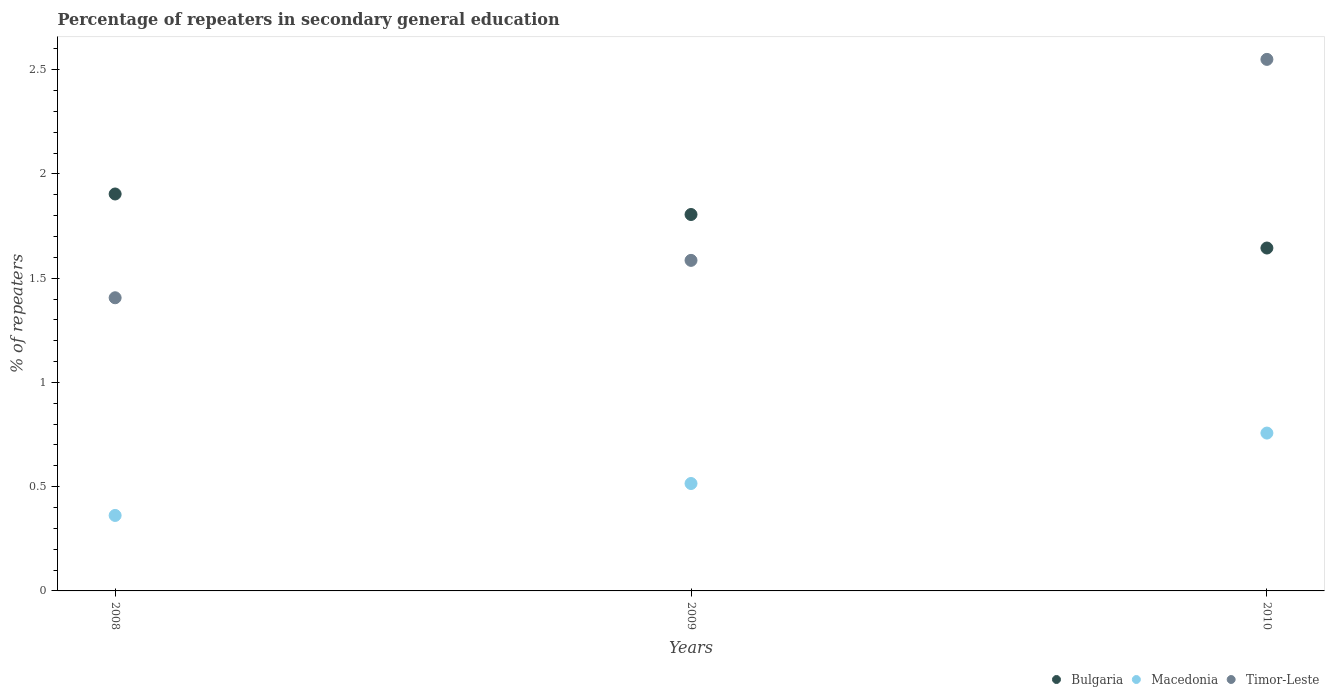How many different coloured dotlines are there?
Offer a terse response. 3. What is the percentage of repeaters in secondary general education in Bulgaria in 2009?
Ensure brevity in your answer.  1.81. Across all years, what is the maximum percentage of repeaters in secondary general education in Macedonia?
Keep it short and to the point. 0.76. Across all years, what is the minimum percentage of repeaters in secondary general education in Timor-Leste?
Your answer should be very brief. 1.41. In which year was the percentage of repeaters in secondary general education in Bulgaria maximum?
Your answer should be compact. 2008. What is the total percentage of repeaters in secondary general education in Macedonia in the graph?
Keep it short and to the point. 1.63. What is the difference between the percentage of repeaters in secondary general education in Timor-Leste in 2009 and that in 2010?
Make the answer very short. -0.96. What is the difference between the percentage of repeaters in secondary general education in Macedonia in 2010 and the percentage of repeaters in secondary general education in Bulgaria in 2008?
Provide a succinct answer. -1.15. What is the average percentage of repeaters in secondary general education in Macedonia per year?
Your answer should be compact. 0.54. In the year 2009, what is the difference between the percentage of repeaters in secondary general education in Timor-Leste and percentage of repeaters in secondary general education in Macedonia?
Provide a succinct answer. 1.07. In how many years, is the percentage of repeaters in secondary general education in Timor-Leste greater than 1.5 %?
Give a very brief answer. 2. What is the ratio of the percentage of repeaters in secondary general education in Bulgaria in 2008 to that in 2010?
Provide a succinct answer. 1.16. What is the difference between the highest and the second highest percentage of repeaters in secondary general education in Macedonia?
Your answer should be compact. 0.24. What is the difference between the highest and the lowest percentage of repeaters in secondary general education in Macedonia?
Offer a very short reply. 0.4. Is the sum of the percentage of repeaters in secondary general education in Timor-Leste in 2008 and 2009 greater than the maximum percentage of repeaters in secondary general education in Bulgaria across all years?
Your response must be concise. Yes. Is the percentage of repeaters in secondary general education in Macedonia strictly greater than the percentage of repeaters in secondary general education in Bulgaria over the years?
Provide a short and direct response. No. What is the difference between two consecutive major ticks on the Y-axis?
Provide a succinct answer. 0.5. How many legend labels are there?
Keep it short and to the point. 3. What is the title of the graph?
Offer a very short reply. Percentage of repeaters in secondary general education. What is the label or title of the X-axis?
Provide a succinct answer. Years. What is the label or title of the Y-axis?
Provide a succinct answer. % of repeaters. What is the % of repeaters in Bulgaria in 2008?
Your response must be concise. 1.9. What is the % of repeaters in Macedonia in 2008?
Your response must be concise. 0.36. What is the % of repeaters of Timor-Leste in 2008?
Offer a very short reply. 1.41. What is the % of repeaters in Bulgaria in 2009?
Your answer should be compact. 1.81. What is the % of repeaters in Macedonia in 2009?
Keep it short and to the point. 0.52. What is the % of repeaters in Timor-Leste in 2009?
Offer a terse response. 1.59. What is the % of repeaters of Bulgaria in 2010?
Provide a succinct answer. 1.64. What is the % of repeaters in Macedonia in 2010?
Your answer should be compact. 0.76. What is the % of repeaters of Timor-Leste in 2010?
Provide a short and direct response. 2.55. Across all years, what is the maximum % of repeaters in Bulgaria?
Your response must be concise. 1.9. Across all years, what is the maximum % of repeaters of Macedonia?
Offer a very short reply. 0.76. Across all years, what is the maximum % of repeaters in Timor-Leste?
Your response must be concise. 2.55. Across all years, what is the minimum % of repeaters of Bulgaria?
Ensure brevity in your answer.  1.64. Across all years, what is the minimum % of repeaters in Macedonia?
Give a very brief answer. 0.36. Across all years, what is the minimum % of repeaters of Timor-Leste?
Offer a very short reply. 1.41. What is the total % of repeaters in Bulgaria in the graph?
Your answer should be very brief. 5.35. What is the total % of repeaters of Macedonia in the graph?
Keep it short and to the point. 1.63. What is the total % of repeaters in Timor-Leste in the graph?
Provide a short and direct response. 5.54. What is the difference between the % of repeaters in Bulgaria in 2008 and that in 2009?
Keep it short and to the point. 0.1. What is the difference between the % of repeaters of Macedonia in 2008 and that in 2009?
Keep it short and to the point. -0.15. What is the difference between the % of repeaters in Timor-Leste in 2008 and that in 2009?
Your answer should be very brief. -0.18. What is the difference between the % of repeaters of Bulgaria in 2008 and that in 2010?
Ensure brevity in your answer.  0.26. What is the difference between the % of repeaters of Macedonia in 2008 and that in 2010?
Your response must be concise. -0.4. What is the difference between the % of repeaters of Timor-Leste in 2008 and that in 2010?
Ensure brevity in your answer.  -1.14. What is the difference between the % of repeaters of Bulgaria in 2009 and that in 2010?
Your answer should be compact. 0.16. What is the difference between the % of repeaters in Macedonia in 2009 and that in 2010?
Offer a very short reply. -0.24. What is the difference between the % of repeaters in Timor-Leste in 2009 and that in 2010?
Provide a succinct answer. -0.96. What is the difference between the % of repeaters of Bulgaria in 2008 and the % of repeaters of Macedonia in 2009?
Ensure brevity in your answer.  1.39. What is the difference between the % of repeaters of Bulgaria in 2008 and the % of repeaters of Timor-Leste in 2009?
Your answer should be compact. 0.32. What is the difference between the % of repeaters of Macedonia in 2008 and the % of repeaters of Timor-Leste in 2009?
Keep it short and to the point. -1.22. What is the difference between the % of repeaters of Bulgaria in 2008 and the % of repeaters of Macedonia in 2010?
Your answer should be compact. 1.15. What is the difference between the % of repeaters of Bulgaria in 2008 and the % of repeaters of Timor-Leste in 2010?
Offer a very short reply. -0.65. What is the difference between the % of repeaters of Macedonia in 2008 and the % of repeaters of Timor-Leste in 2010?
Keep it short and to the point. -2.19. What is the difference between the % of repeaters of Bulgaria in 2009 and the % of repeaters of Macedonia in 2010?
Offer a very short reply. 1.05. What is the difference between the % of repeaters in Bulgaria in 2009 and the % of repeaters in Timor-Leste in 2010?
Offer a very short reply. -0.74. What is the difference between the % of repeaters in Macedonia in 2009 and the % of repeaters in Timor-Leste in 2010?
Offer a very short reply. -2.03. What is the average % of repeaters in Bulgaria per year?
Your response must be concise. 1.78. What is the average % of repeaters in Macedonia per year?
Ensure brevity in your answer.  0.54. What is the average % of repeaters in Timor-Leste per year?
Provide a succinct answer. 1.85. In the year 2008, what is the difference between the % of repeaters of Bulgaria and % of repeaters of Macedonia?
Offer a very short reply. 1.54. In the year 2008, what is the difference between the % of repeaters of Bulgaria and % of repeaters of Timor-Leste?
Offer a very short reply. 0.5. In the year 2008, what is the difference between the % of repeaters of Macedonia and % of repeaters of Timor-Leste?
Keep it short and to the point. -1.04. In the year 2009, what is the difference between the % of repeaters of Bulgaria and % of repeaters of Macedonia?
Provide a short and direct response. 1.29. In the year 2009, what is the difference between the % of repeaters of Bulgaria and % of repeaters of Timor-Leste?
Offer a terse response. 0.22. In the year 2009, what is the difference between the % of repeaters in Macedonia and % of repeaters in Timor-Leste?
Make the answer very short. -1.07. In the year 2010, what is the difference between the % of repeaters of Bulgaria and % of repeaters of Macedonia?
Offer a very short reply. 0.89. In the year 2010, what is the difference between the % of repeaters in Bulgaria and % of repeaters in Timor-Leste?
Give a very brief answer. -0.9. In the year 2010, what is the difference between the % of repeaters of Macedonia and % of repeaters of Timor-Leste?
Your answer should be compact. -1.79. What is the ratio of the % of repeaters of Bulgaria in 2008 to that in 2009?
Provide a short and direct response. 1.05. What is the ratio of the % of repeaters in Macedonia in 2008 to that in 2009?
Provide a succinct answer. 0.7. What is the ratio of the % of repeaters of Timor-Leste in 2008 to that in 2009?
Ensure brevity in your answer.  0.89. What is the ratio of the % of repeaters in Bulgaria in 2008 to that in 2010?
Give a very brief answer. 1.16. What is the ratio of the % of repeaters of Macedonia in 2008 to that in 2010?
Provide a short and direct response. 0.48. What is the ratio of the % of repeaters in Timor-Leste in 2008 to that in 2010?
Your answer should be very brief. 0.55. What is the ratio of the % of repeaters in Bulgaria in 2009 to that in 2010?
Offer a terse response. 1.1. What is the ratio of the % of repeaters of Macedonia in 2009 to that in 2010?
Ensure brevity in your answer.  0.68. What is the ratio of the % of repeaters in Timor-Leste in 2009 to that in 2010?
Offer a terse response. 0.62. What is the difference between the highest and the second highest % of repeaters of Bulgaria?
Provide a short and direct response. 0.1. What is the difference between the highest and the second highest % of repeaters in Macedonia?
Provide a succinct answer. 0.24. What is the difference between the highest and the second highest % of repeaters of Timor-Leste?
Offer a terse response. 0.96. What is the difference between the highest and the lowest % of repeaters of Bulgaria?
Provide a succinct answer. 0.26. What is the difference between the highest and the lowest % of repeaters of Macedonia?
Provide a short and direct response. 0.4. What is the difference between the highest and the lowest % of repeaters in Timor-Leste?
Offer a terse response. 1.14. 